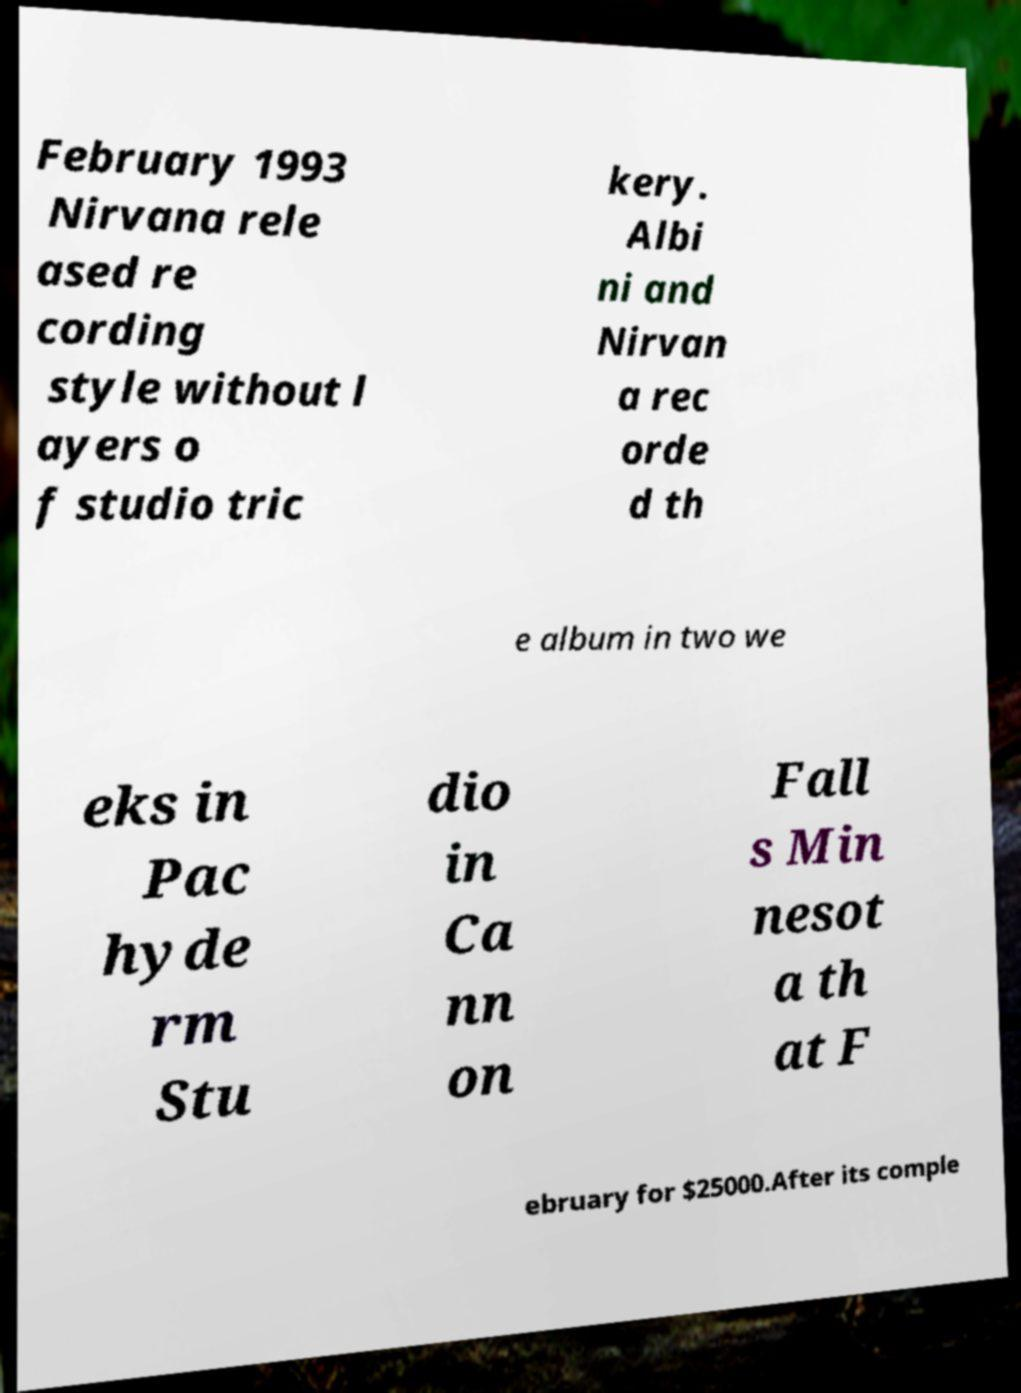There's text embedded in this image that I need extracted. Can you transcribe it verbatim? February 1993 Nirvana rele ased re cording style without l ayers o f studio tric kery. Albi ni and Nirvan a rec orde d th e album in two we eks in Pac hyde rm Stu dio in Ca nn on Fall s Min nesot a th at F ebruary for $25000.After its comple 